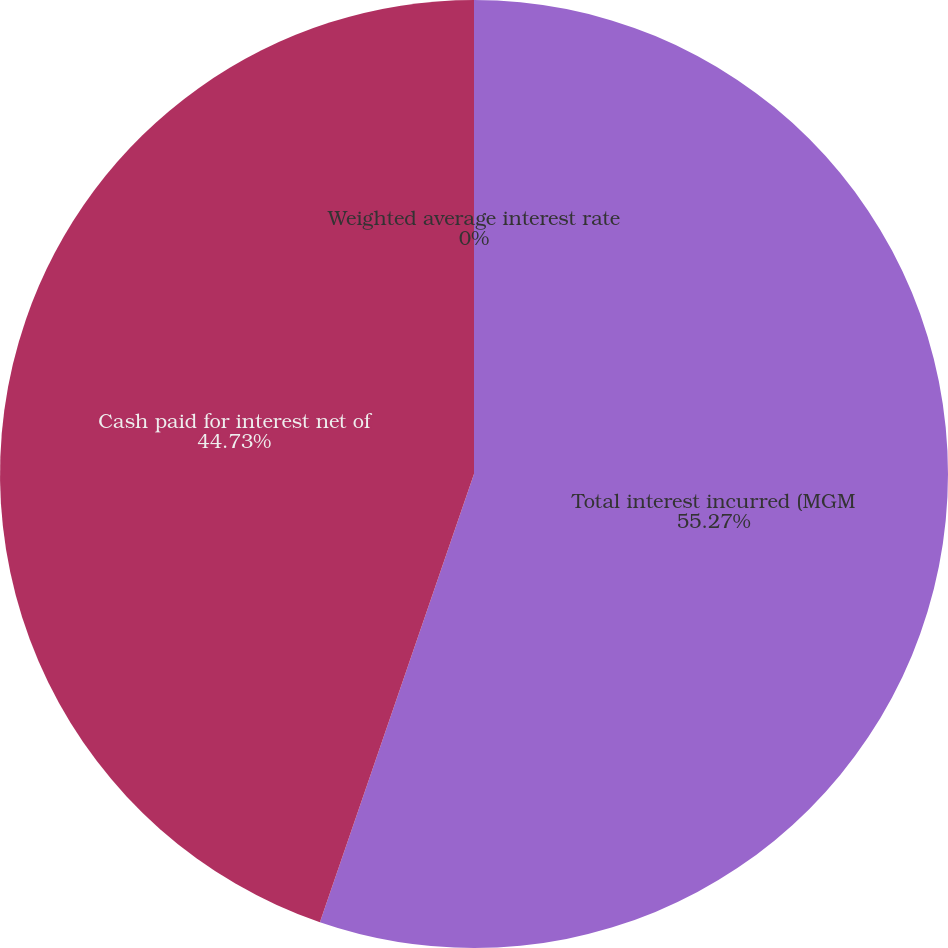<chart> <loc_0><loc_0><loc_500><loc_500><pie_chart><fcel>Total interest incurred (MGM<fcel>Cash paid for interest net of<fcel>Weighted average interest rate<nl><fcel>55.27%<fcel>44.73%<fcel>0.0%<nl></chart> 